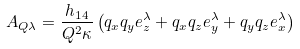Convert formula to latex. <formula><loc_0><loc_0><loc_500><loc_500>A _ { { Q } \lambda } = \frac { h _ { 1 4 } } { Q ^ { 2 } \kappa } \left ( q _ { x } q _ { y } e ^ { \lambda } _ { z } + q _ { x } q _ { z } e ^ { \lambda } _ { y } + q _ { y } q _ { z } e ^ { \lambda } _ { x } \right )</formula> 